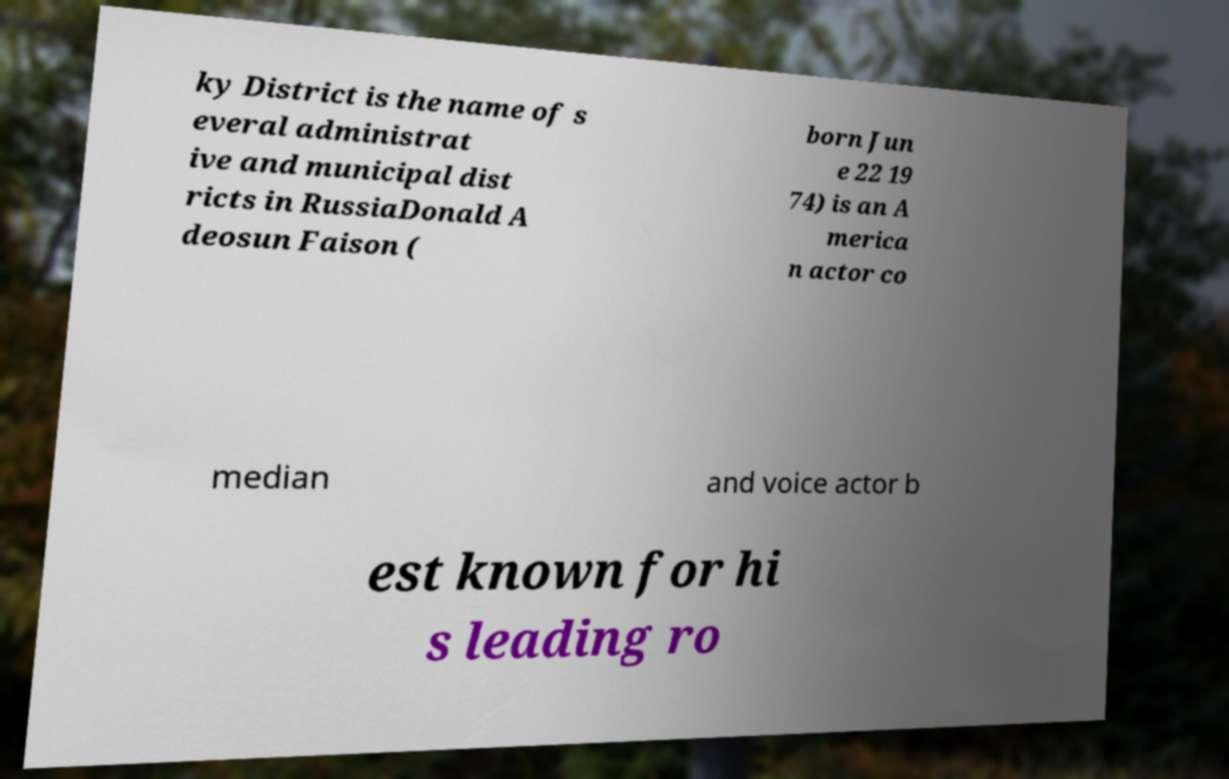Can you accurately transcribe the text from the provided image for me? ky District is the name of s everal administrat ive and municipal dist ricts in RussiaDonald A deosun Faison ( born Jun e 22 19 74) is an A merica n actor co median and voice actor b est known for hi s leading ro 